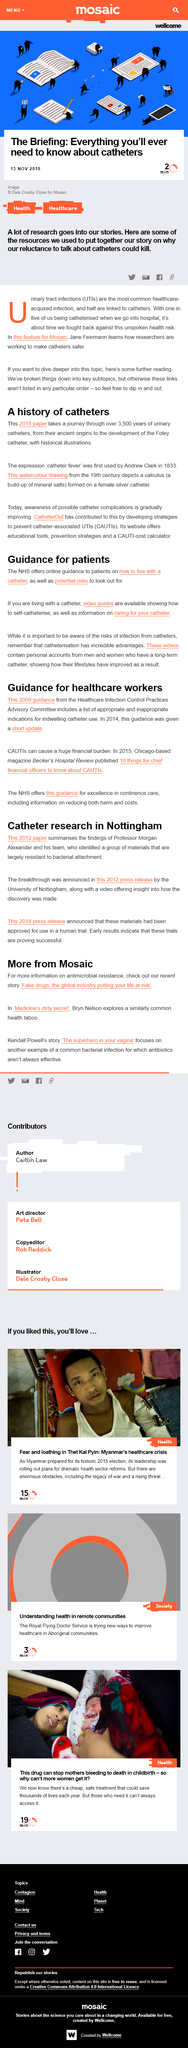Point out several critical features in this image. Bryn Nelson did not write an article on the superhero in your vagina in addition to an article on medicine's dirty little secret. The University of Nottingham released a 2012 press release announcing a breakthrough in the field of sustainable construction technology. According to early results, these trials are proving to be successful. Urinary Tract Infection is a common medical condition defined by the presence of microorganisms in the urinary tract, leading to symptoms such as burning sensation during urination, frequent urination, and abdominal pain. Its acronym, UTI, refers to this specific medical condition. Antibiotics are not always effective in treating common bacterial infections, as they are not effective against viral infections, and some bacteria have become resistant to the drugs that were once effective against them. 